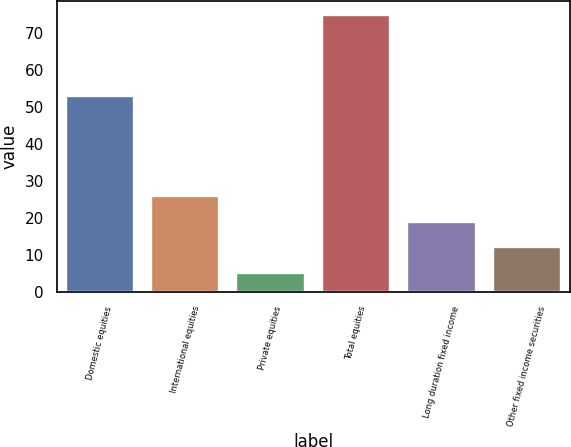<chart> <loc_0><loc_0><loc_500><loc_500><bar_chart><fcel>Domestic equities<fcel>International equities<fcel>Private equities<fcel>Total equities<fcel>Long duration fixed income<fcel>Other fixed income securities<nl><fcel>53<fcel>26<fcel>5<fcel>75<fcel>19<fcel>12<nl></chart> 